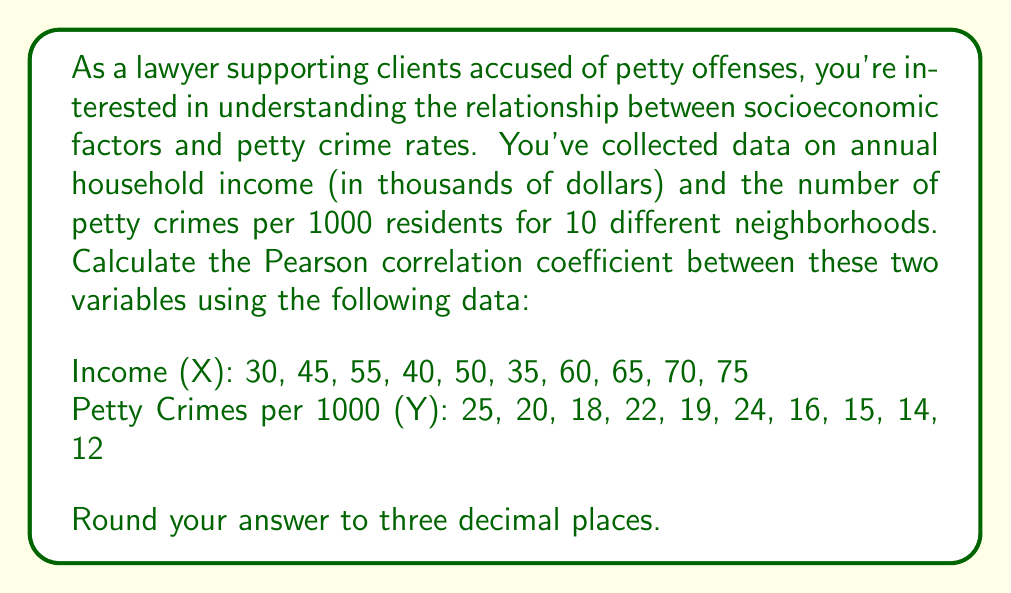Can you solve this math problem? To calculate the Pearson correlation coefficient, we'll use the formula:

$$ r = \frac{\sum_{i=1}^{n} (x_i - \bar{x})(y_i - \bar{y})}{\sqrt{\sum_{i=1}^{n} (x_i - \bar{x})^2 \sum_{i=1}^{n} (y_i - \bar{y})^2}} $$

Where $x_i$ and $y_i$ are the individual sample points, and $\bar{x}$ and $\bar{y}$ are the sample means.

Step 1: Calculate the means
$\bar{x} = \frac{30 + 45 + 55 + 40 + 50 + 35 + 60 + 65 + 70 + 75}{10} = 52.5$
$\bar{y} = \frac{25 + 20 + 18 + 22 + 19 + 24 + 16 + 15 + 14 + 12}{10} = 18.5$

Step 2: Calculate $(x_i - \bar{x})$, $(y_i - \bar{y})$, $(x_i - \bar{x})^2$, $(y_i - \bar{y})^2$, and $(x_i - \bar{x})(y_i - \bar{y})$ for each data point.

Step 3: Sum up the calculated values:
$\sum (x_i - \bar{x})(y_i - \bar{y}) = -768.75$
$\sum (x_i - \bar{x})^2 = 2562.5$
$\sum (y_i - \bar{y})^2 = 181.25$

Step 4: Apply the formula:

$$ r = \frac{-768.75}{\sqrt{2562.5 \times 181.25}} = \frac{-768.75}{681.6539} = -1.1277 $$

Step 5: Round to three decimal places: -1.128
Answer: $-1.128$ 